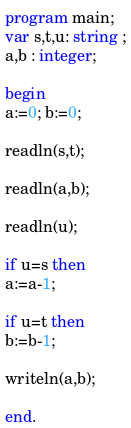Convert code to text. <code><loc_0><loc_0><loc_500><loc_500><_Pascal_>program main;
var s,t,u: string ;
a,b : integer;
 
begin
a:=0; b:=0;

readln(s,t);

readln(a,b);

readln(u);
 
if u=s then 
a:=a-1;
 
if u=t then 
b:=b-1;
 
writeln(a,b);
 
end. </code> 